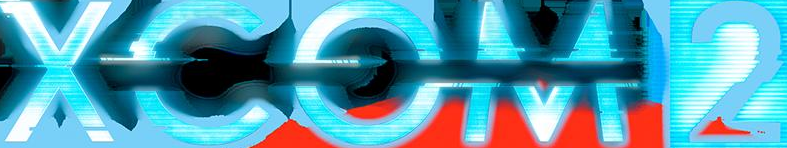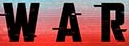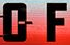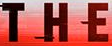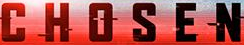What words are shown in these images in order, separated by a semicolon? XCOM2; WAR; OF; THE; CHOSEN 